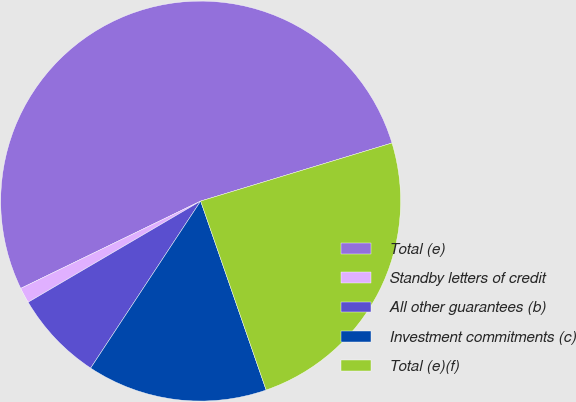Convert chart to OTSL. <chart><loc_0><loc_0><loc_500><loc_500><pie_chart><fcel>Total (e)<fcel>Standby letters of credit<fcel>All other guarantees (b)<fcel>Investment commitments (c)<fcel>Total (e)(f)<nl><fcel>52.5%<fcel>1.25%<fcel>7.29%<fcel>14.58%<fcel>24.38%<nl></chart> 